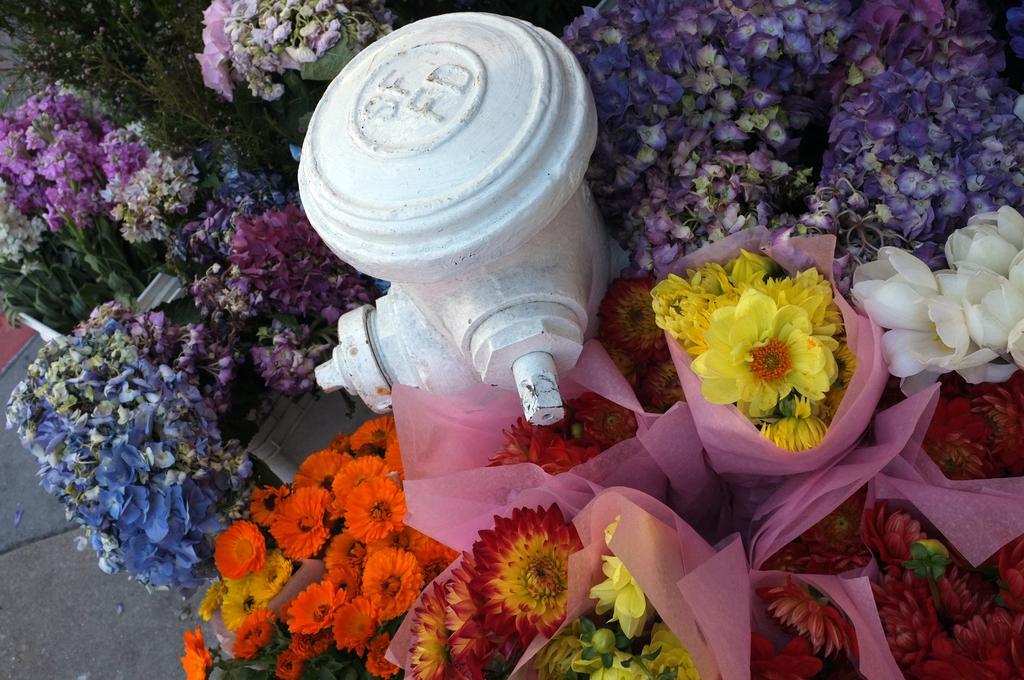Can you describe this image briefly? In the picture we can see fire hydrant which is in white color and there are some flower bouquets around it. 